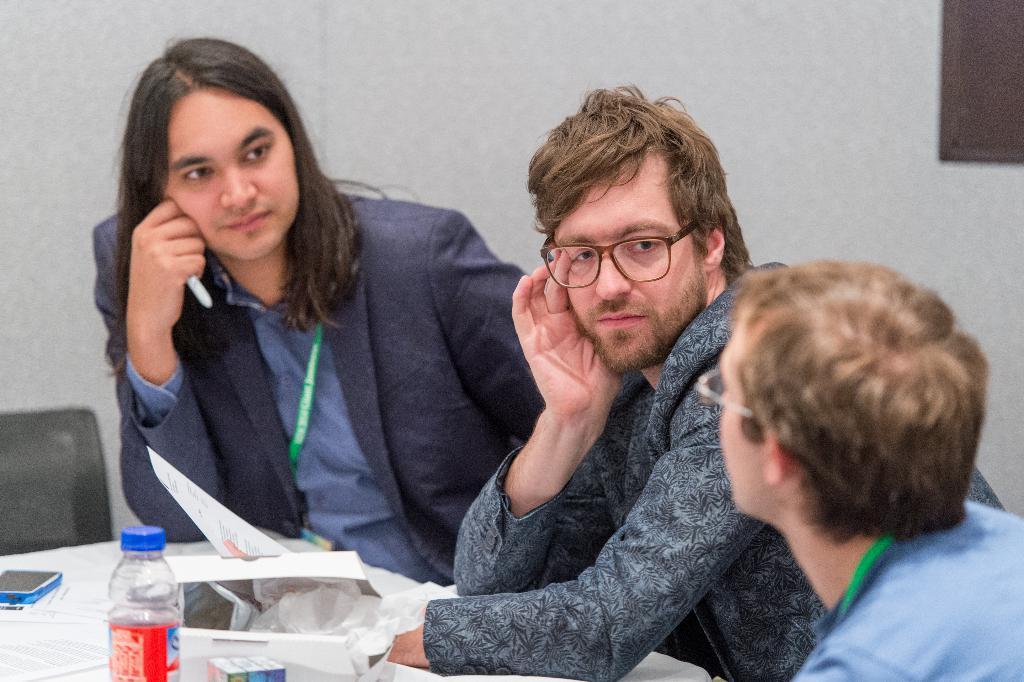How would you summarize this image in a sentence or two? The picture is taken inside a room. Three men are sitting on chairs, they are wearing suits. In front of of them on a table there is bottle, packet. The person in the middle is holding a paper. In the background there is wall. 